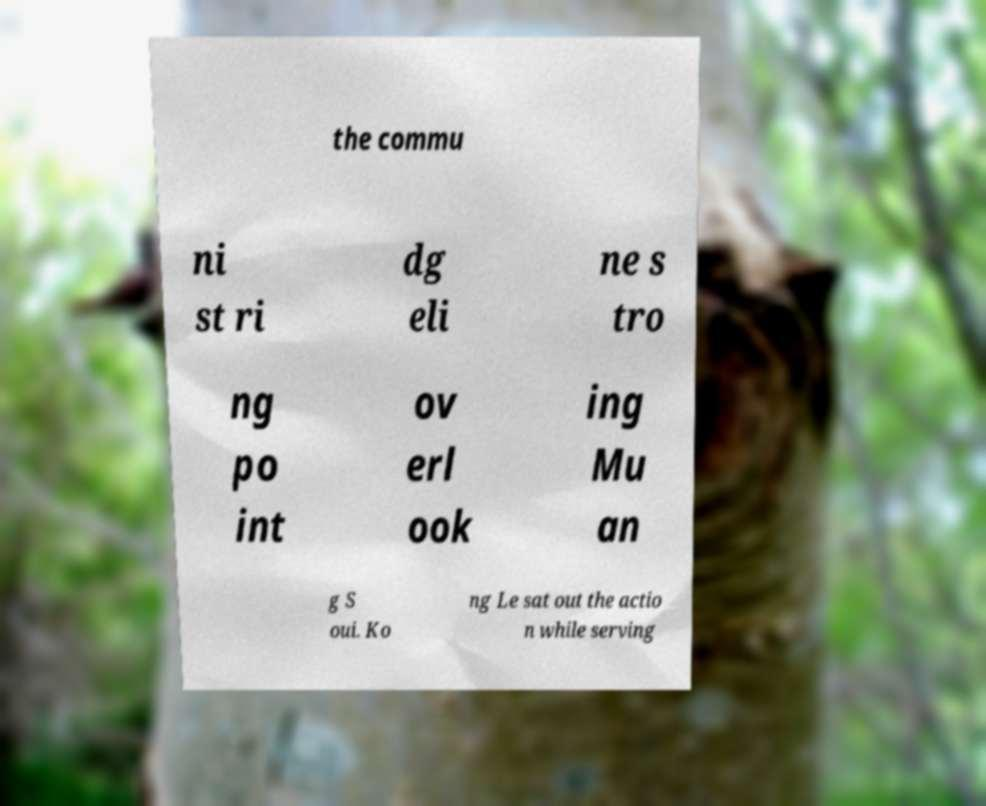Can you accurately transcribe the text from the provided image for me? the commu ni st ri dg eli ne s tro ng po int ov erl ook ing Mu an g S oui. Ko ng Le sat out the actio n while serving 